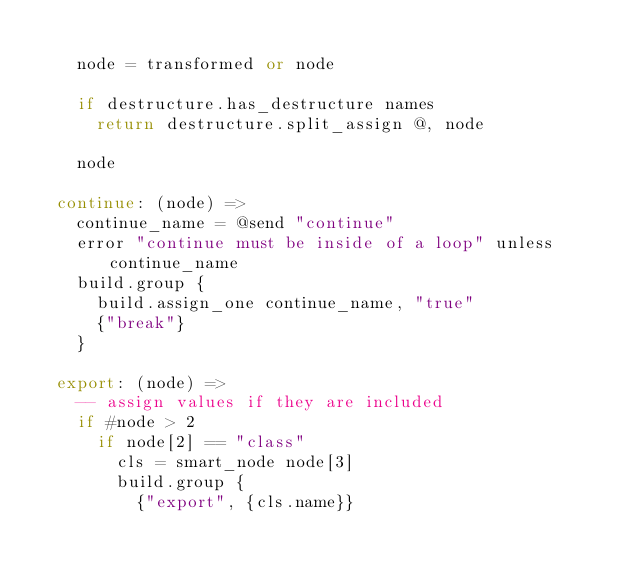<code> <loc_0><loc_0><loc_500><loc_500><_MoonScript_>
    node = transformed or node

    if destructure.has_destructure names
      return destructure.split_assign @, node

    node

  continue: (node) =>
    continue_name = @send "continue"
    error "continue must be inside of a loop" unless continue_name
    build.group {
      build.assign_one continue_name, "true"
      {"break"}
    }

  export: (node) =>
    -- assign values if they are included
    if #node > 2
      if node[2] == "class"
        cls = smart_node node[3]
        build.group {
          {"export", {cls.name}}</code> 